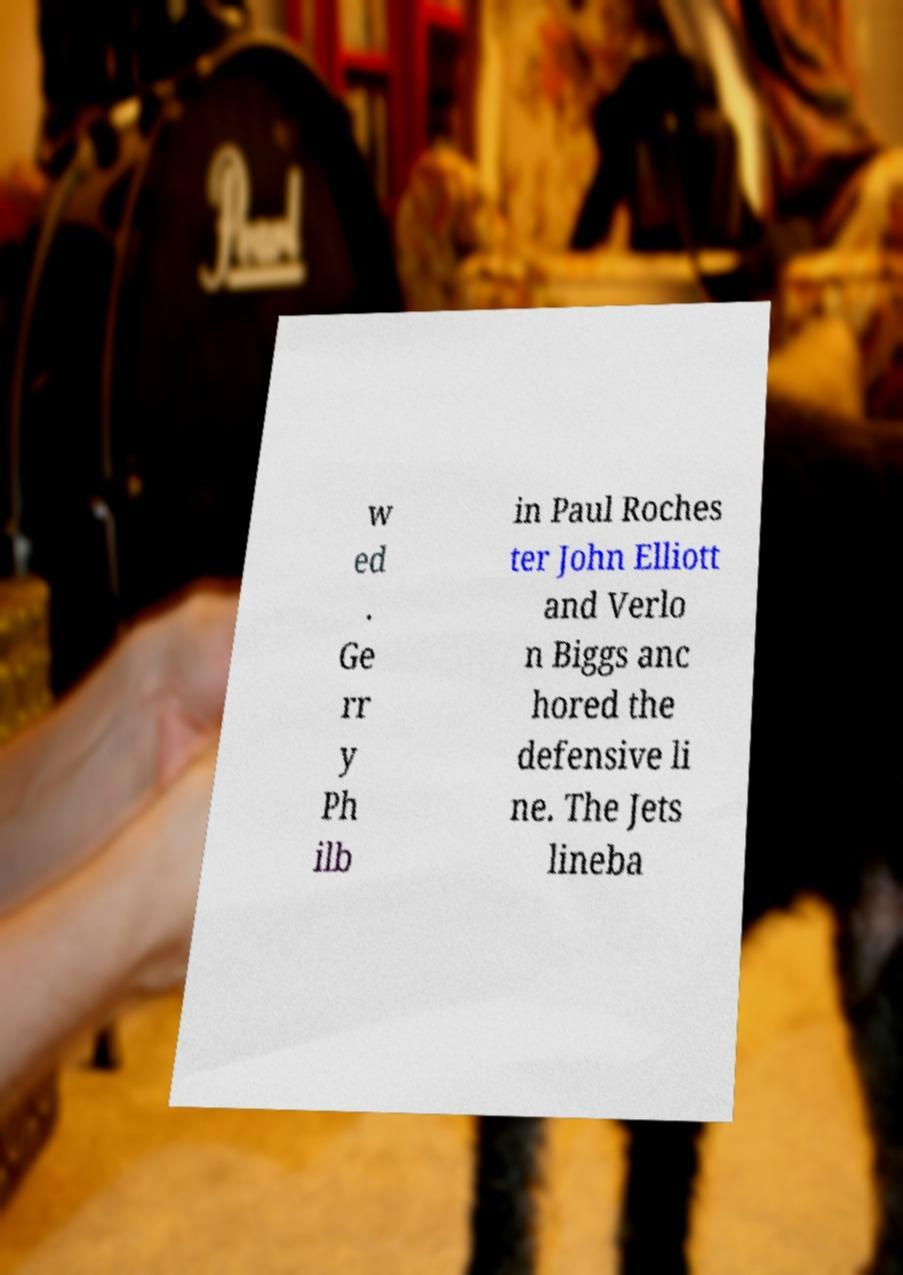For documentation purposes, I need the text within this image transcribed. Could you provide that? w ed . Ge rr y Ph ilb in Paul Roches ter John Elliott and Verlo n Biggs anc hored the defensive li ne. The Jets lineba 